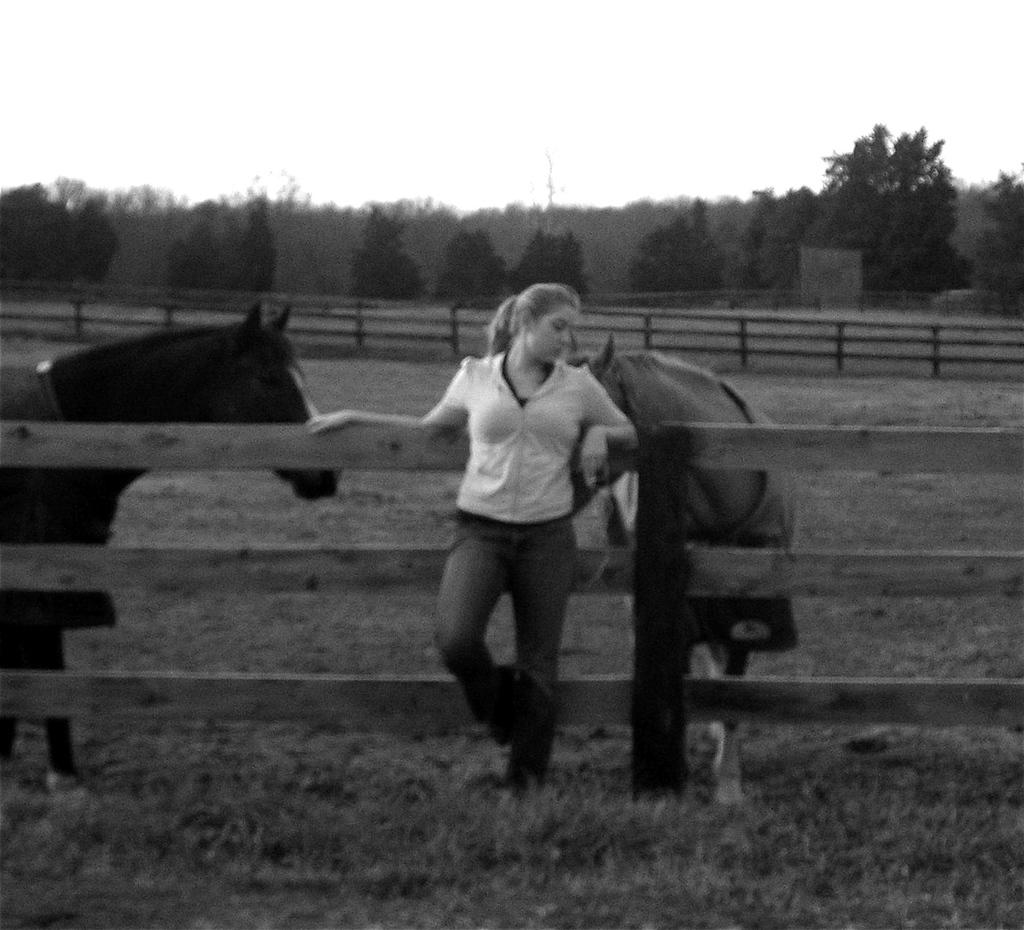Who is the main subject in the image? There is a woman in the image. What is the woman doing in the image? The woman is standing with her head back. What animals are present in the image? There are two horses behind the woman. What type of natural environment is visible in the image? Trees and the sky are visible in the image. What type of animal is the woman seeking approval from in the image? There is no animal present in the image, and the woman is not seeking approval from any animal. 